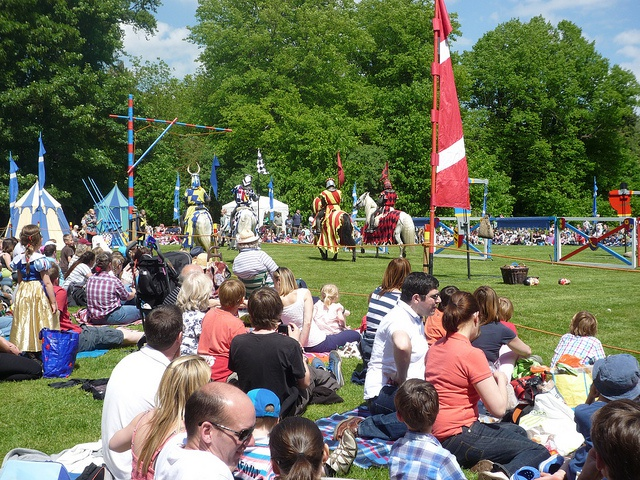Describe the objects in this image and their specific colors. I can see people in black, white, olive, and gray tones, people in black, white, gray, and navy tones, people in black, white, lightpink, and gray tones, people in black, white, gray, and darkgray tones, and people in black, gray, and maroon tones in this image. 